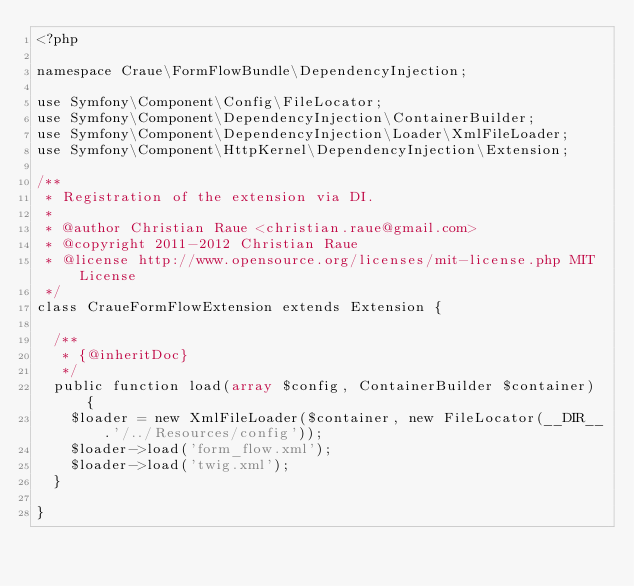<code> <loc_0><loc_0><loc_500><loc_500><_PHP_><?php

namespace Craue\FormFlowBundle\DependencyInjection;

use Symfony\Component\Config\FileLocator;
use Symfony\Component\DependencyInjection\ContainerBuilder;
use Symfony\Component\DependencyInjection\Loader\XmlFileLoader;
use Symfony\Component\HttpKernel\DependencyInjection\Extension;

/**
 * Registration of the extension via DI.
 *
 * @author Christian Raue <christian.raue@gmail.com>
 * @copyright 2011-2012 Christian Raue
 * @license http://www.opensource.org/licenses/mit-license.php MIT License
 */
class CraueFormFlowExtension extends Extension {

	/**
	 * {@inheritDoc}
	 */
	public function load(array $config, ContainerBuilder $container) {
		$loader = new XmlFileLoader($container, new FileLocator(__DIR__.'/../Resources/config'));
		$loader->load('form_flow.xml');
		$loader->load('twig.xml');
	}

}
</code> 